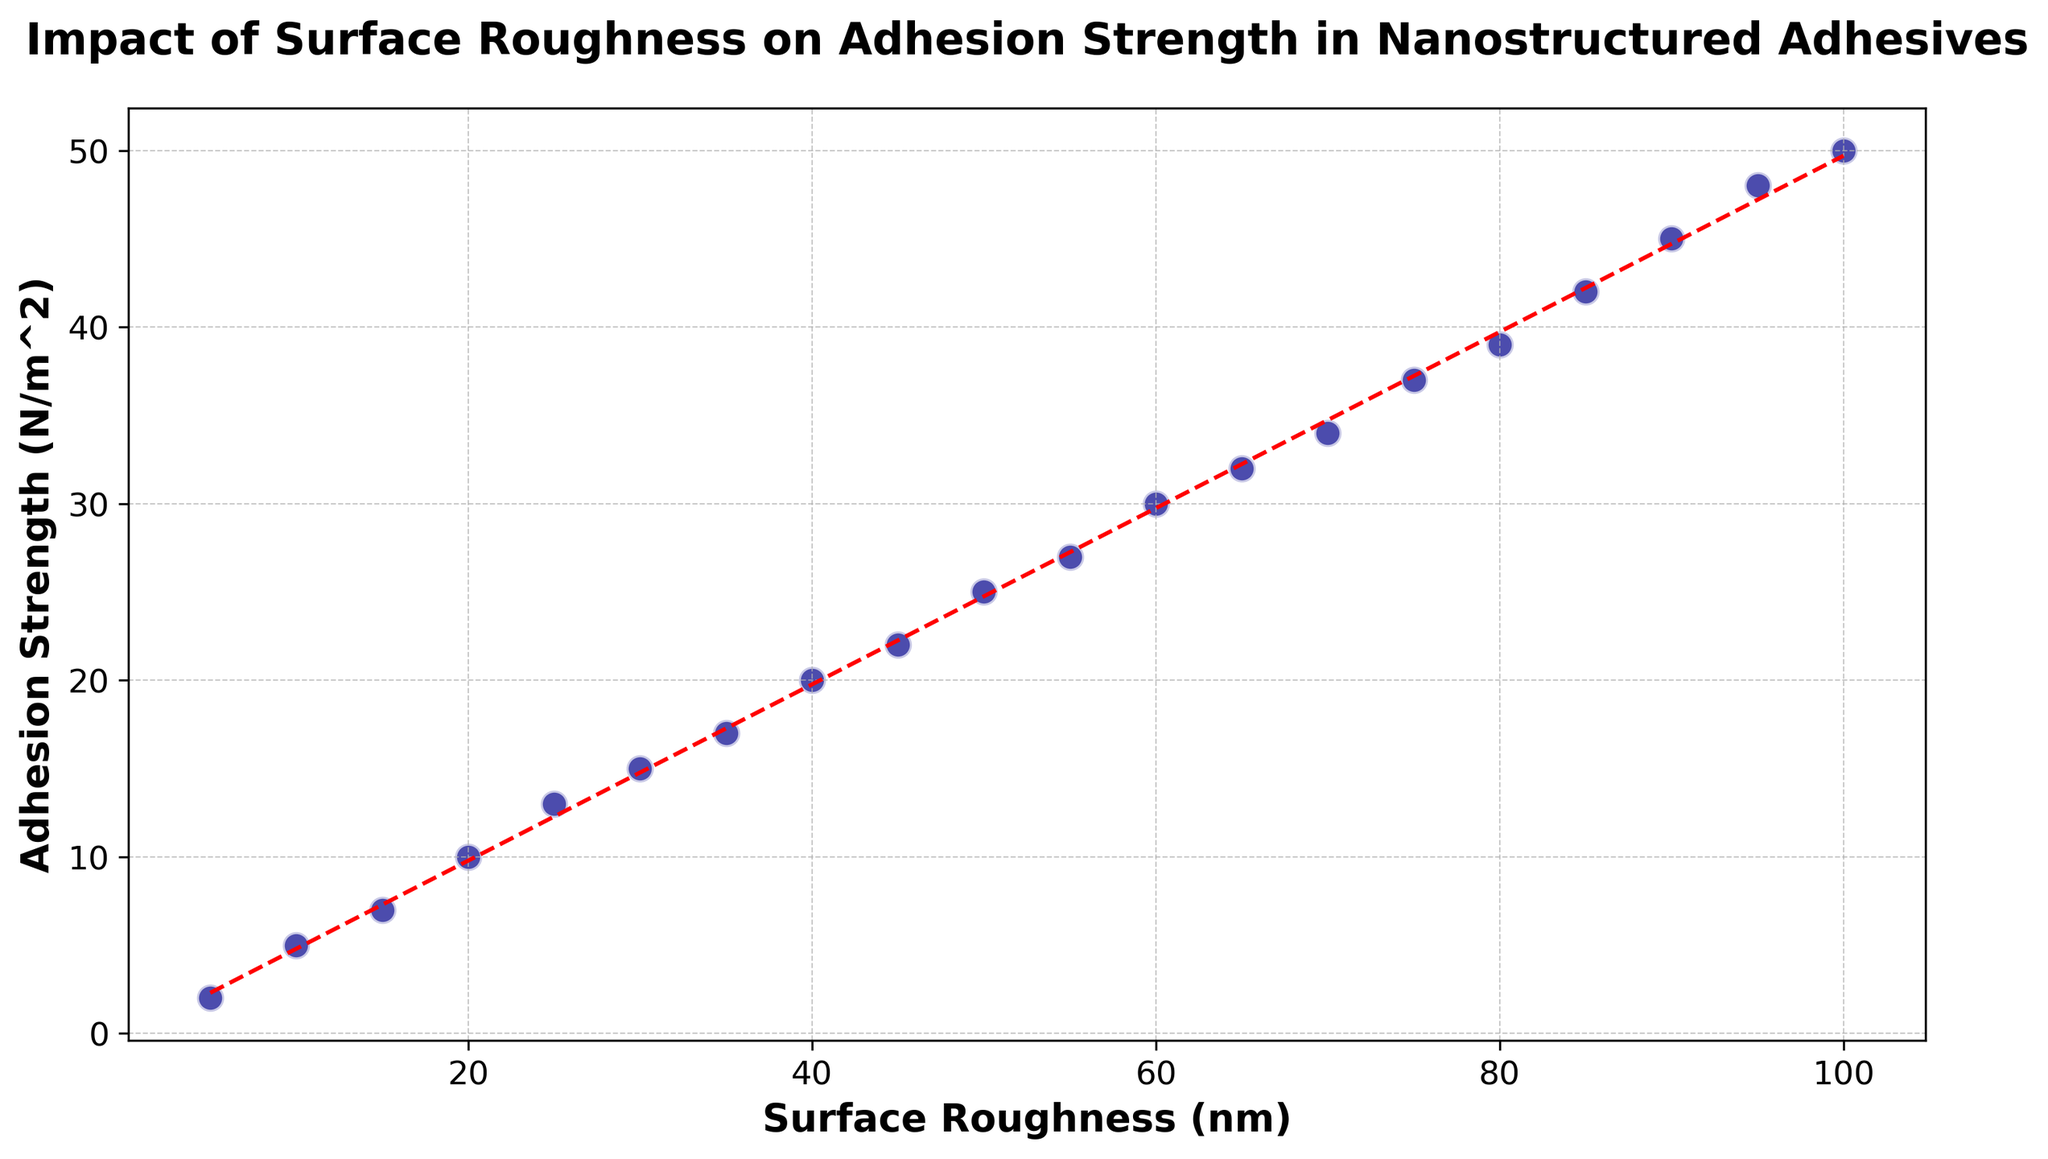What is the general trend between surface roughness and adhesion strength? Observing the scatter plot, as the surface roughness increases, the adhesion strength also tends to increase. This trend is further highlighted by the red dashed trend line.
Answer: As surface roughness increases, adhesion strength increases Which data point has the highest surface roughness and what is its corresponding adhesion strength? The data point with the highest surface roughness is at 100 nm, and its corresponding adhesion strength is 50 N/m^2. This is the topmost point on the X-axis in the scatter plot.
Answer: Surface roughness 100 nm, adhesion strength 50 N/m^2 Is there any visible outlier in the scatter plot? Considering the scatter plot, all data points tend to follow a linear trend, and there are no points that deviate significantly from this trend. Therefore, there are no outliers.
Answer: No Compare the adhesion strength when the surface roughness is 20 nm and 60 nm. Which one is greater and by how much? Observing the data points, the adhesion strength at 20 nm surface roughness is 10 N/m^2, and at 60 nm it is 30 N/m^2. The difference is calculated as 30 - 10.
Answer: 60 nm is greater by 20 N/m^2 What is the average adhesion strength for surface roughness values of 25 nm, 50 nm, and 75 nm? The adhesion strength for surface roughness 25 nm is 13 N/m^2, for 50 nm is 25 N/m^2, and for 75 nm is 37 N/m^2. The average is calculated as (13 + 25 + 37) / 3.
Answer: 25 N/m^2 Which data point is closest to the trend line at 40 nm surface roughness? Observing the scatter plot, the data point at 40 nm surface roughness has an adhesion strength of 20 N/m^2. By referencing the trend line, this point is in close agreement with the linear trend line.
Answer: 40 nm, adhesion strength 20 N/m^2 What is the rough estimate of adhesion strength if the surface roughness is increased to 110 nm, according to the trend line? The trend line shows a consistent linear relationship. Extrapolating from the given data, a rough estimate at 110 nm surface roughness can be made by extending the slope (surface roughness increasing by 10 nm results in adhesion strength increasing by 5 N/m^2). So, approximating 110 nm, adhesion strength would be around 55 N/m^2.
Answer: 55 N/m^2 Considering the scatter plot, does the surface roughness have a stronger positive correlation with adhesion strength or a negative one? Observing the scatter plot and the linear trend line, the relationship between surface roughness and adhesion strength shows a strong positive correlation. As surface roughness increases, adhesion strength also increases.
Answer: Positive correlation How does the adhesion strength change on average for every 20 nm increase in surface roughness? Reviewing the scatter plot and data: adhesion strength increases by about 10 N/m^2 for every 20 nm increase in surface roughness.
Answer: Increases by 10 N/m^2 